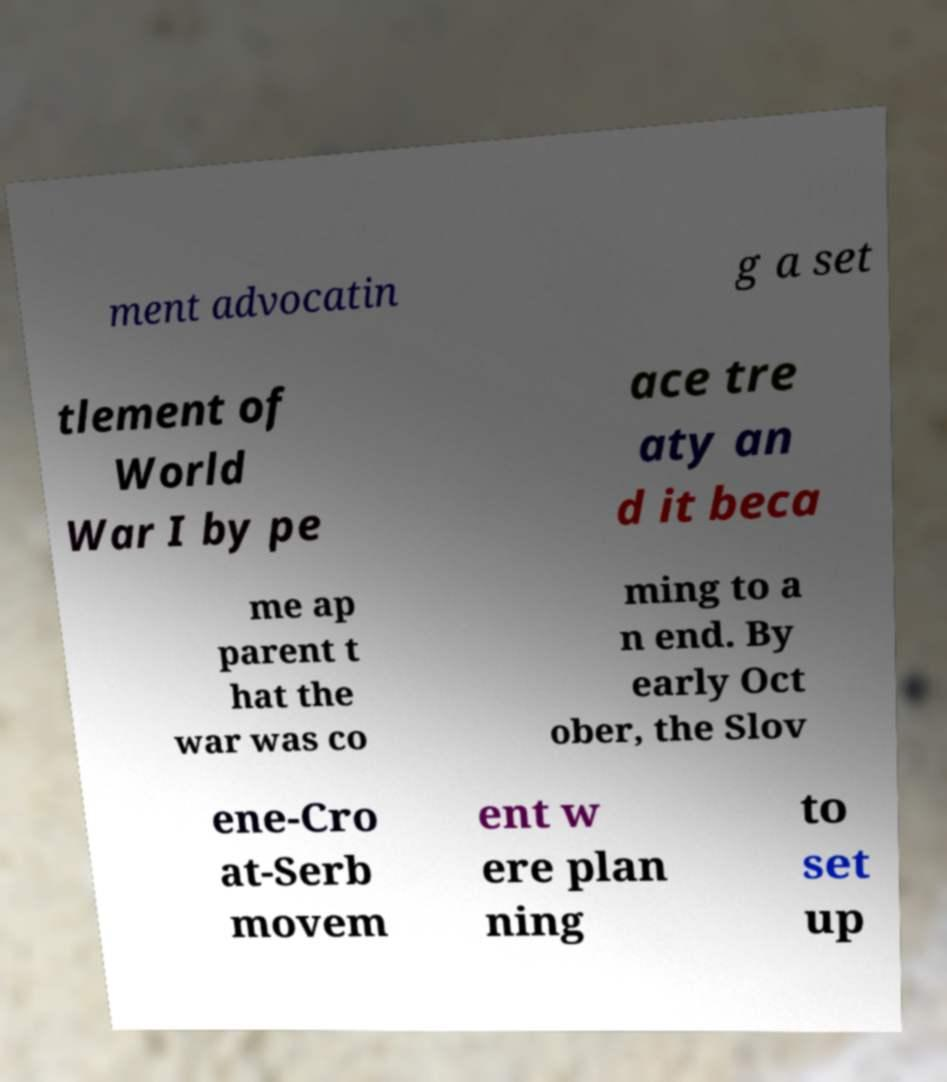Please read and relay the text visible in this image. What does it say? ment advocatin g a set tlement of World War I by pe ace tre aty an d it beca me ap parent t hat the war was co ming to a n end. By early Oct ober, the Slov ene-Cro at-Serb movem ent w ere plan ning to set up 